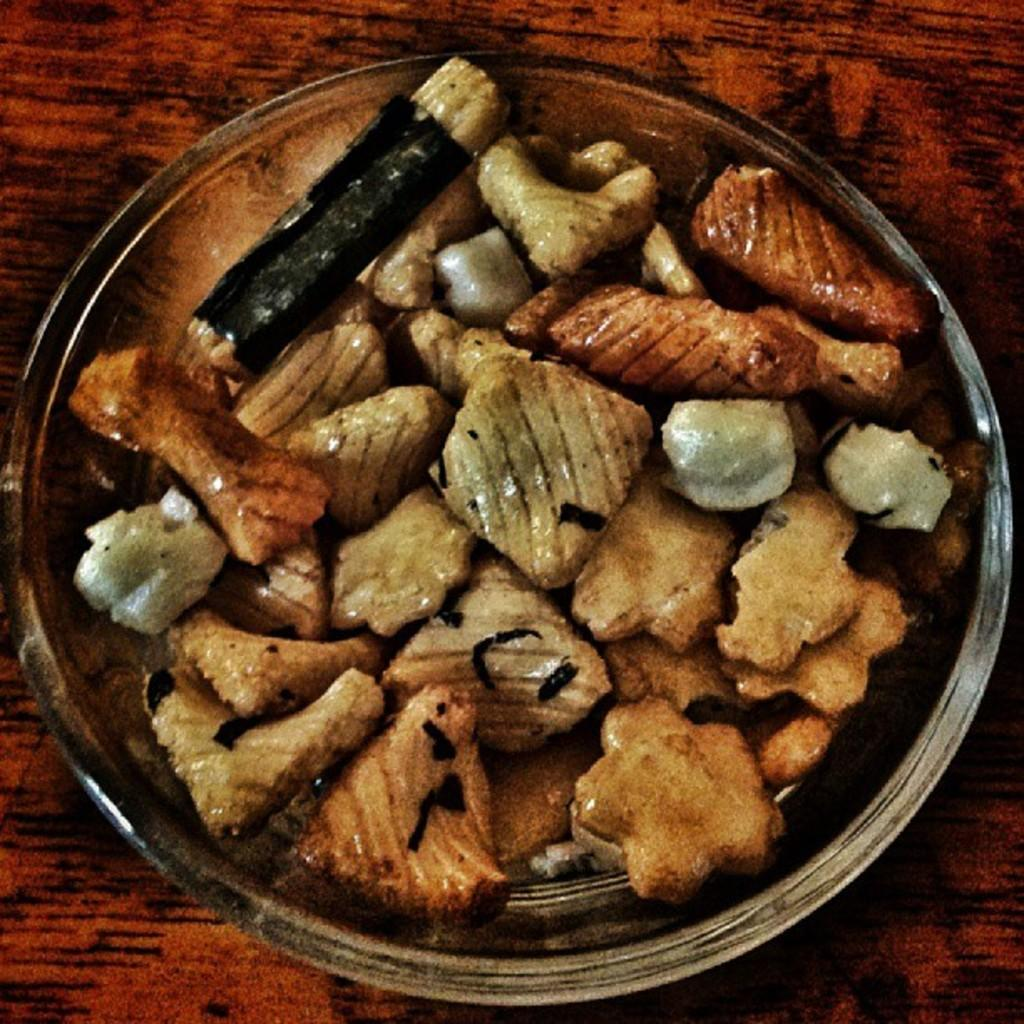What is in the bowl that is visible in the image? The bowl contains food items. What is the bowl placed on in the image? The bowl is placed on top of an object. What type of fuel is being used to power the earth in the image? There is no mention of the earth or fuel in the image; it only features a bowl with food items. 